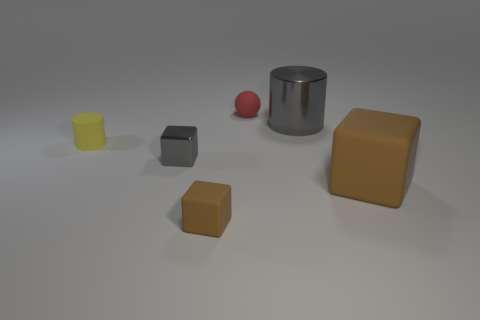Is there a gray object? Yes, there is a gray object in the image. It appears to be a small, cubical shape positioned between a yellow cylinder and a brown cube. 